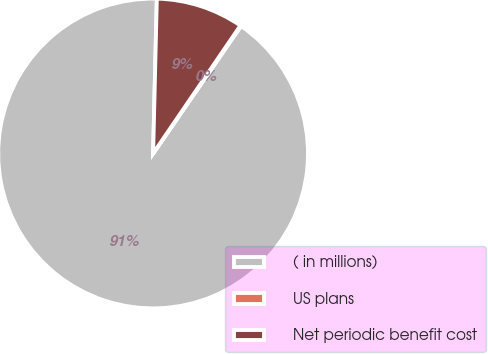Convert chart to OTSL. <chart><loc_0><loc_0><loc_500><loc_500><pie_chart><fcel>( in millions)<fcel>US plans<fcel>Net periodic benefit cost<nl><fcel>90.78%<fcel>0.08%<fcel>9.15%<nl></chart> 